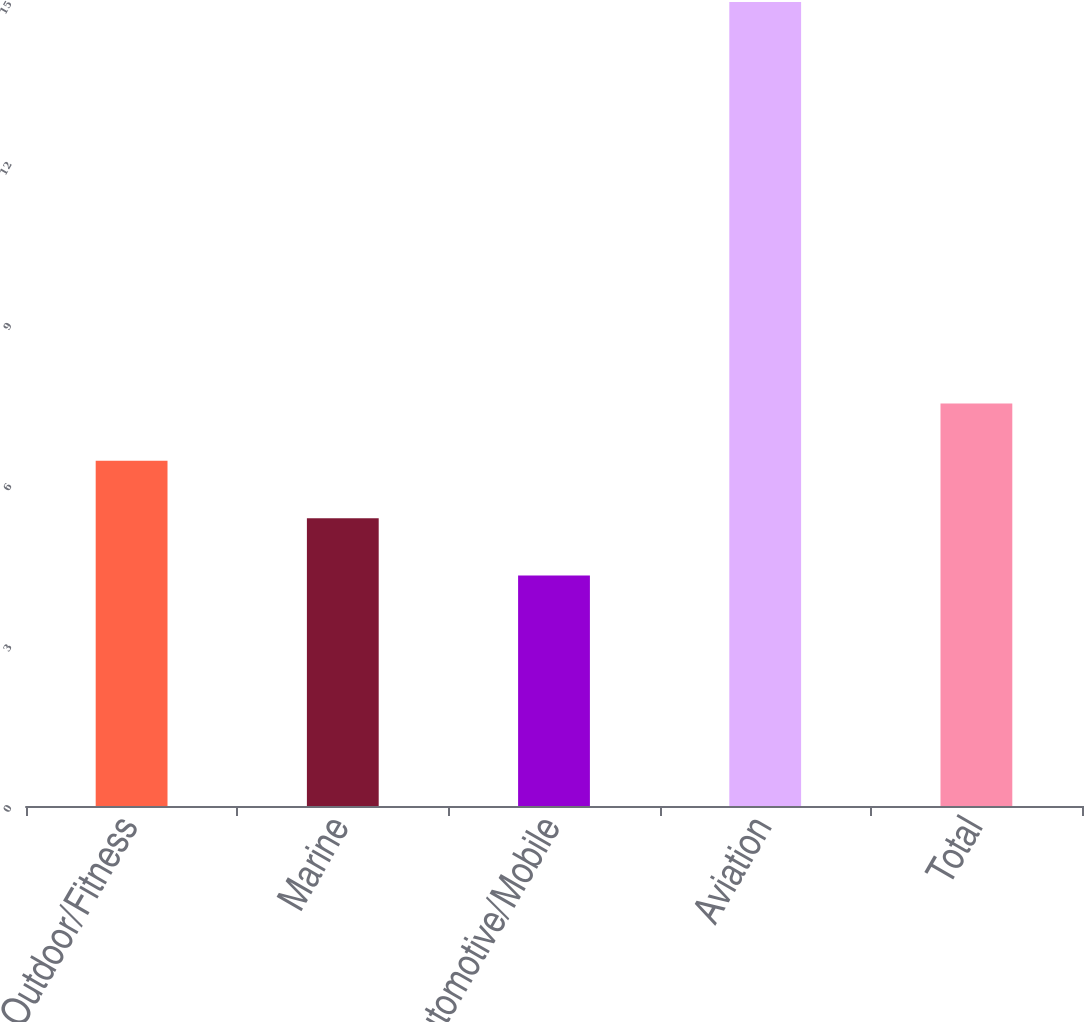Convert chart. <chart><loc_0><loc_0><loc_500><loc_500><bar_chart><fcel>Outdoor/Fitness<fcel>Marine<fcel>Automotive/Mobile<fcel>Aviation<fcel>Total<nl><fcel>6.44<fcel>5.37<fcel>4.3<fcel>15<fcel>7.51<nl></chart> 